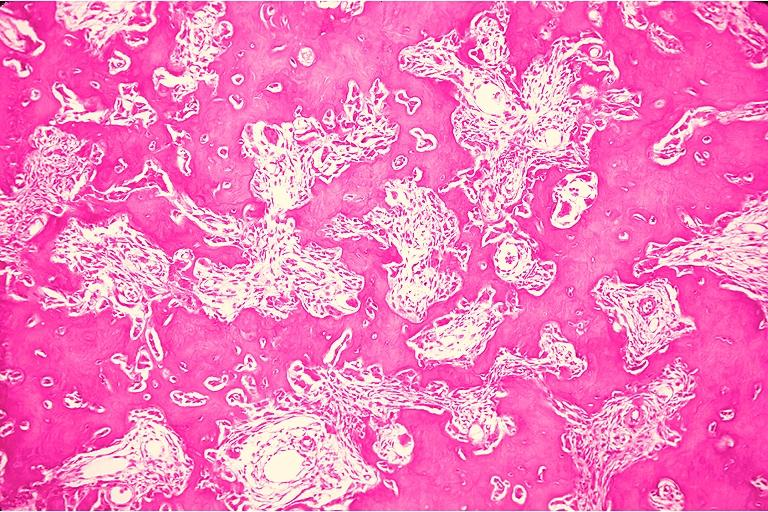does this image show osteoblastoma?
Answer the question using a single word or phrase. Yes 